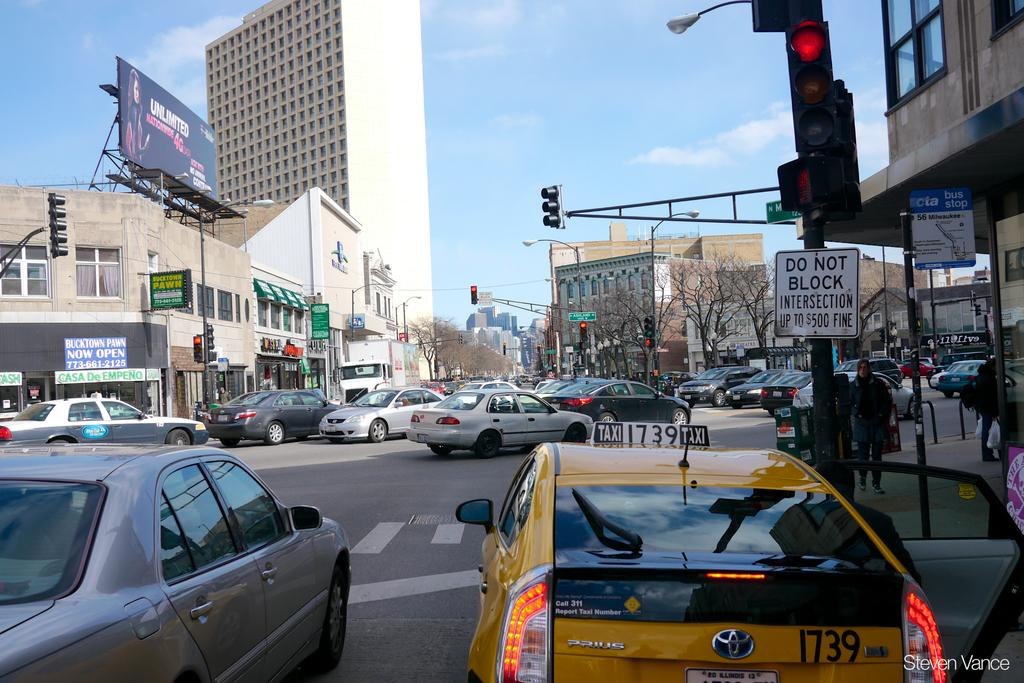<image>
Provide a brief description of the given image. A stoplight with a sign that says do not block intersection and up to 500 dollar fine. 